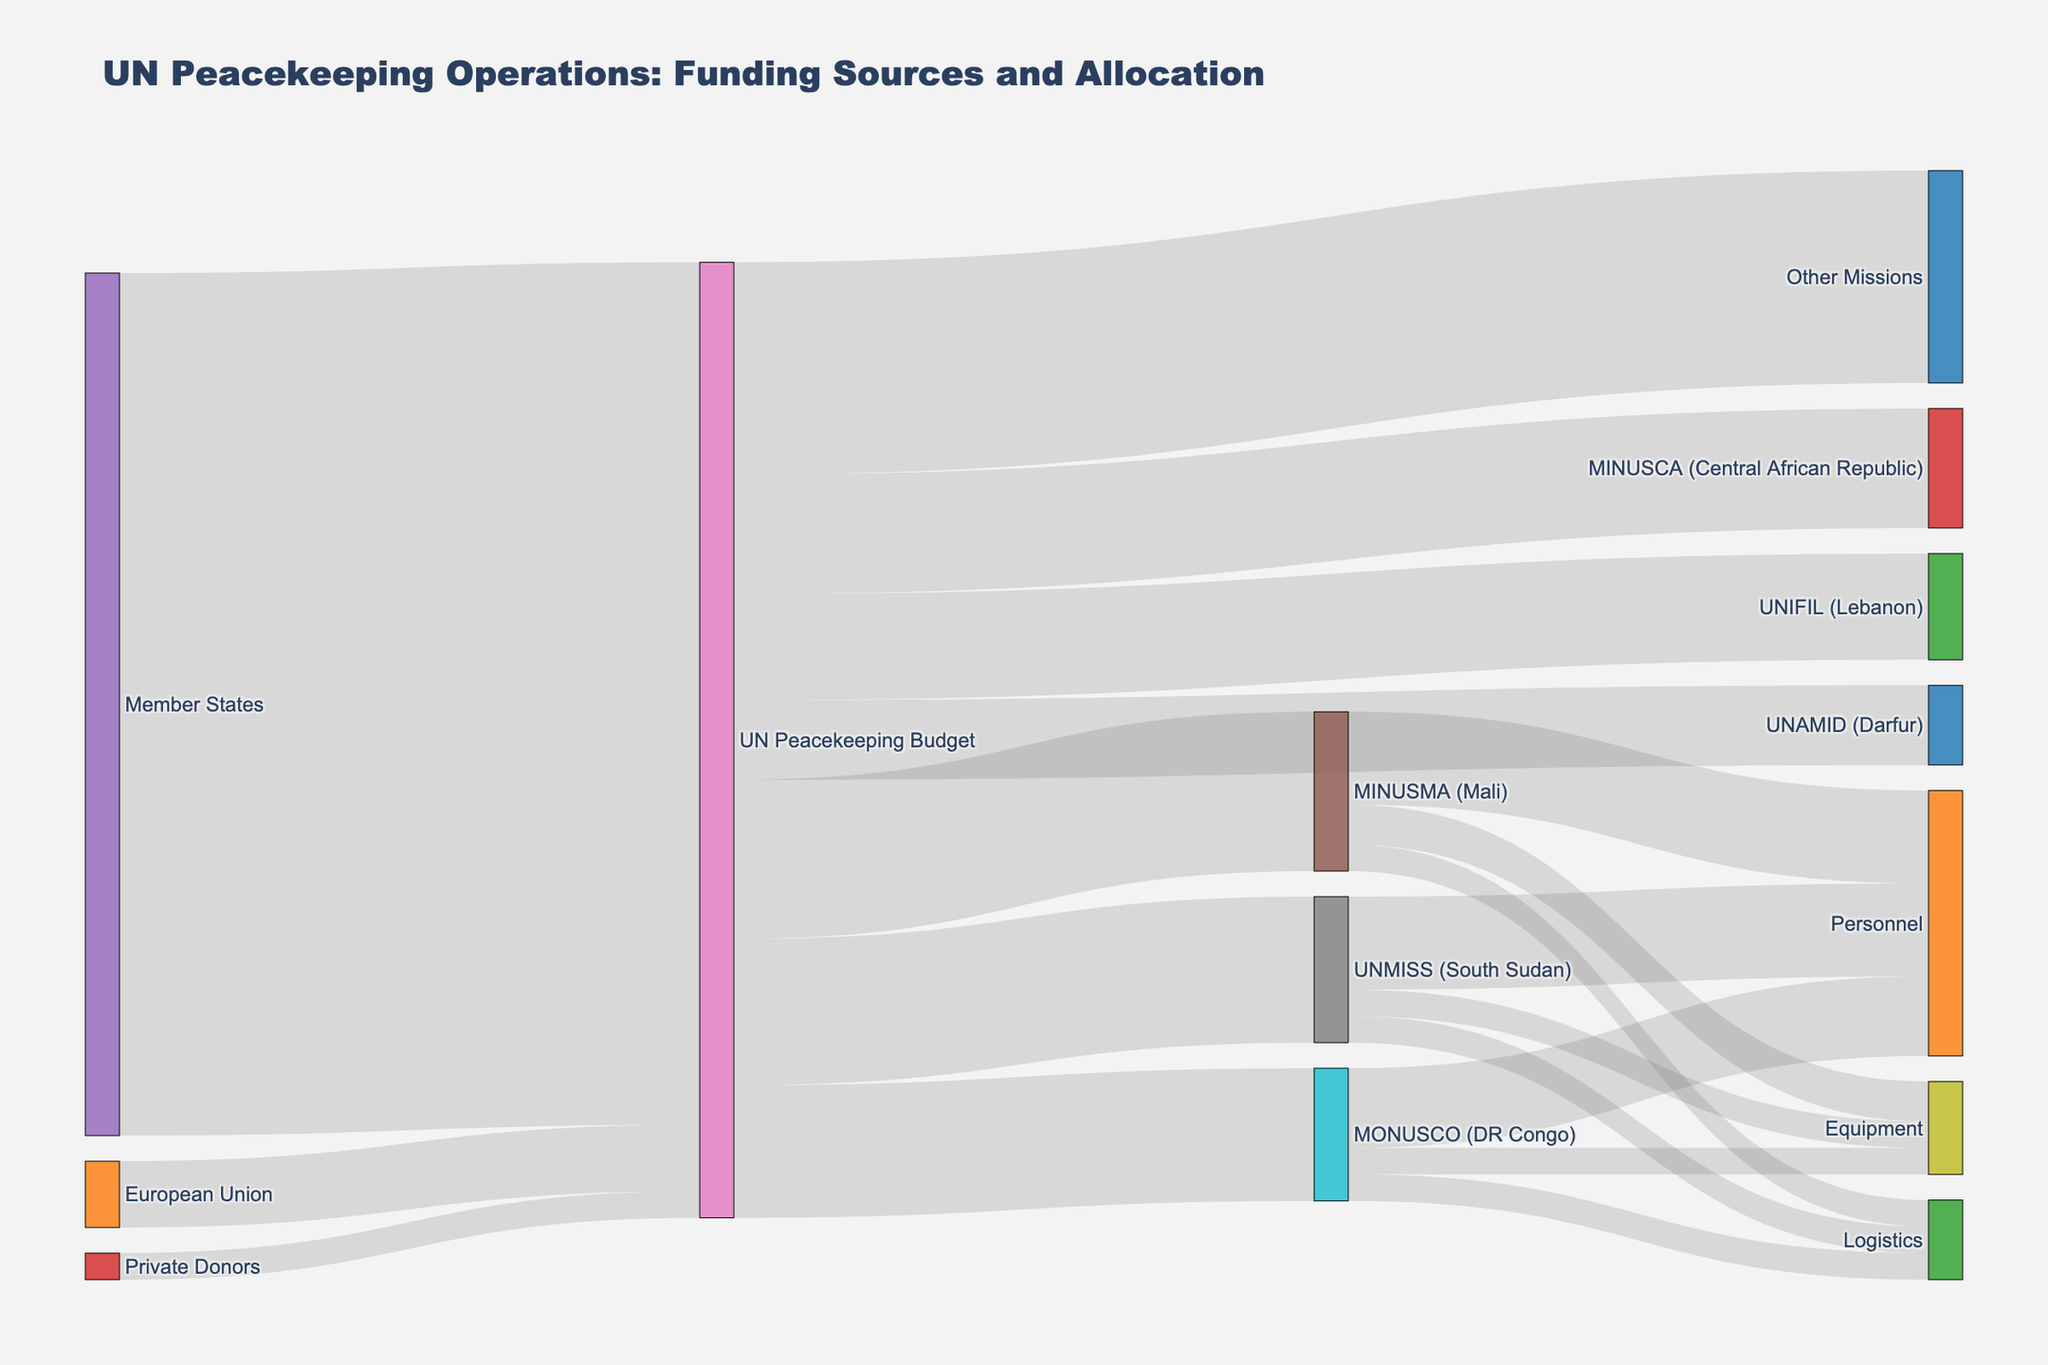Who are the primary funding sources for UN peacekeeping operations? By examining the diagram, we see that the primary funding sources are listed at the leftmost side of the chart. They include Member States, the European Union, and Private Donors.
Answer: Member States, European Union, Private Donors What is the combined funding contribution from Member States and the European Union? According to the diagram, Member States contribute 6.5 units and the European Union contributes 0.5 units. Adding these together gives 6.5 + 0.5 = 7.0 units.
Answer: 7.0 units Which mission receives the largest allocation from the UN Peacekeeping Budget? By observing the thickness of the streams and the numeric values next to them, MINUSMA (Mali) receives 1.2 units, which is the largest allocation among the missions listed.
Answer: MINUSMA (Mali) How much more funding does UNMISS (South Sudan) receive compared to UNIFIL (Lebanon)? From the diagram, UNMISS receives 1.1 units while UNIFIL receives 0.8 units. The difference is calculated as 1.1 - 0.8 = 0.3 units.
Answer: 0.3 units What are the categories of expenditure for MINUSMA (Mali) according to the diagram? Examining the flows extending from MINUSMA (Mali), the categories listed are Personnel, Equipment, and Logistics.
Answer: Personnel, Equipment, Logistics What percent of the UN Peacekeeping Budget is allocated to MINUSCA (Central African Republic) out of the total budget? The total UN Peacekeeping Budget allocated is 1.2 (MINUSMA) + 1.0 (MONUSCO) + 1.1 (UNMISS) + 0.8 (UNIFIL) + 0.9 (MINUSCA) + 0.6 (UNAMID) + 1.6 (Other Missions) = 7.2 units. MINUSCA gets 0.9 units, so the percent allocation is (0.9/7.2) * 100, approximately 12.5%.
Answer: Approximately 12.5% Which category of expenditure receives the most funding from MINUSMA (Mali)? From the flows coming out of MINUSMA (Mali), Personnel receives 0.7 units, Equipment receives 0.3 units, and Logistics receives 0.2 units; hence Personnel receives the most funding.
Answer: Personnel Are the contributions from Private Donors greater than from the European Union? By comparing the values next to the funding sources, the Private Donors contribute 0.2 units while the European Union contributes 0.5 units, so the contributions from the European Union are greater.
Answer: No How does the allocation to MONUSCO (DR Congo) compare with that to UNIFIL (Lebanon)? MONUSCO receives 1.0 units and UNIFIL receives 0.8 units. Thus, MONUSCO receives more funding than UNIFIL.
Answer: MONUSCO receives more 